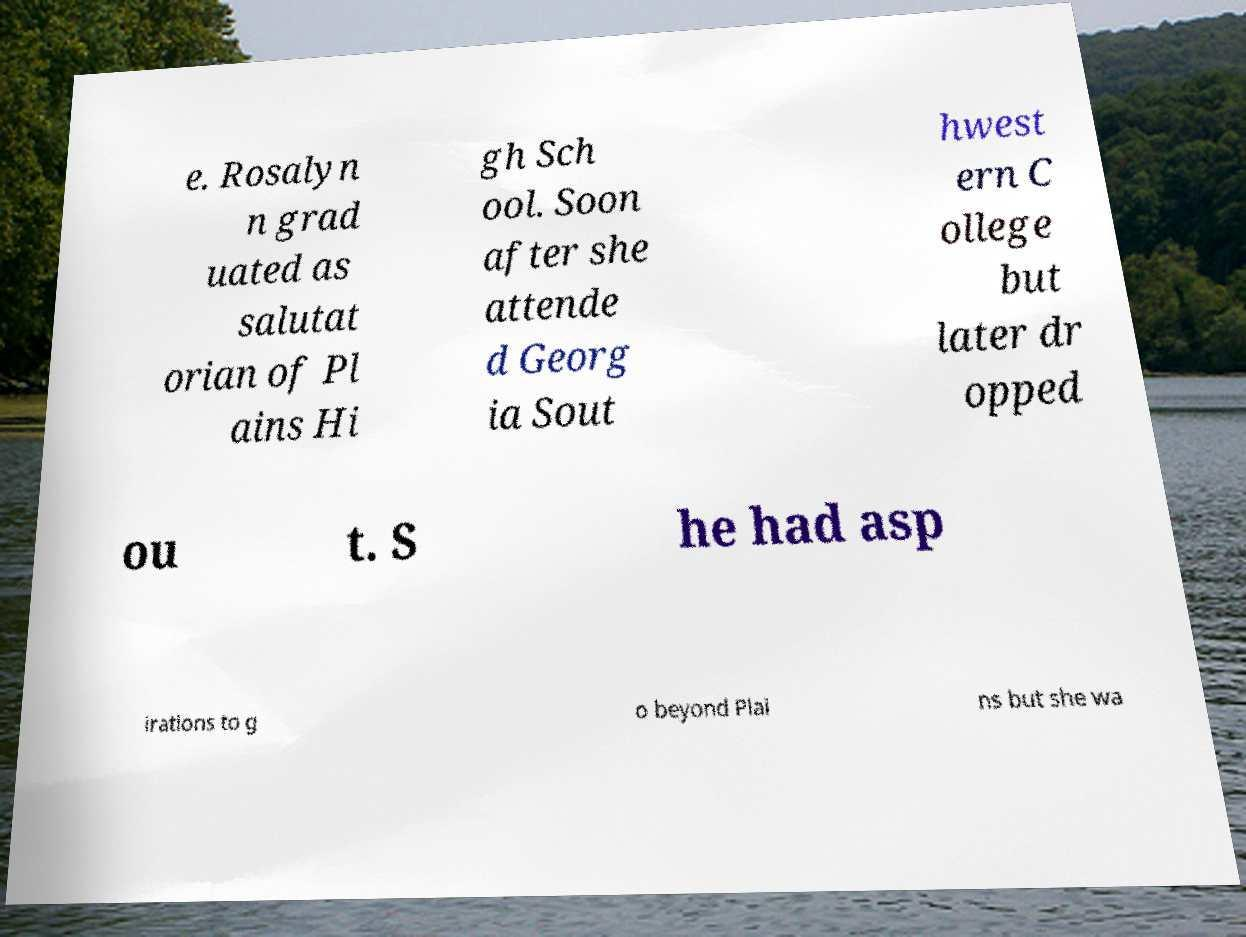Could you extract and type out the text from this image? e. Rosalyn n grad uated as salutat orian of Pl ains Hi gh Sch ool. Soon after she attende d Georg ia Sout hwest ern C ollege but later dr opped ou t. S he had asp irations to g o beyond Plai ns but she wa 